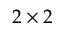<formula> <loc_0><loc_0><loc_500><loc_500>2 \times 2</formula> 